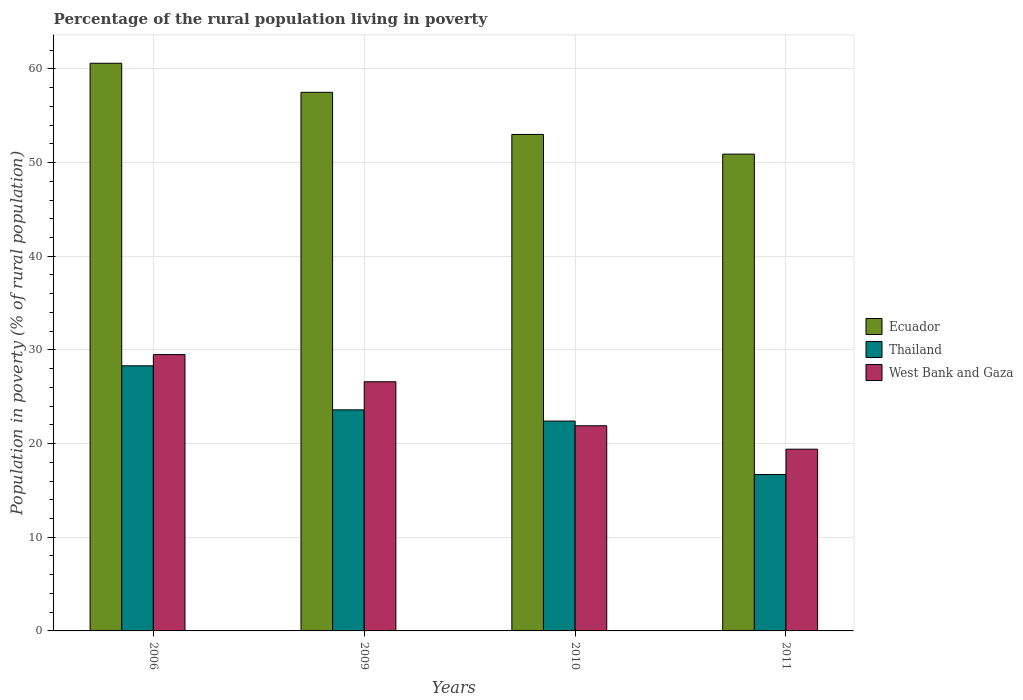How many different coloured bars are there?
Ensure brevity in your answer.  3. How many groups of bars are there?
Give a very brief answer. 4. How many bars are there on the 4th tick from the left?
Your answer should be compact. 3. How many bars are there on the 4th tick from the right?
Make the answer very short. 3. What is the label of the 3rd group of bars from the left?
Provide a succinct answer. 2010. What is the percentage of the rural population living in poverty in West Bank and Gaza in 2009?
Provide a succinct answer. 26.6. Across all years, what is the maximum percentage of the rural population living in poverty in Thailand?
Provide a succinct answer. 28.3. Across all years, what is the minimum percentage of the rural population living in poverty in Thailand?
Provide a short and direct response. 16.7. What is the total percentage of the rural population living in poverty in West Bank and Gaza in the graph?
Your response must be concise. 97.4. What is the difference between the percentage of the rural population living in poverty in Ecuador in 2010 and that in 2011?
Offer a very short reply. 2.1. What is the difference between the percentage of the rural population living in poverty in Ecuador in 2011 and the percentage of the rural population living in poverty in West Bank and Gaza in 2009?
Make the answer very short. 24.3. What is the average percentage of the rural population living in poverty in Thailand per year?
Offer a very short reply. 22.75. In the year 2011, what is the difference between the percentage of the rural population living in poverty in Ecuador and percentage of the rural population living in poverty in West Bank and Gaza?
Provide a short and direct response. 31.5. What is the ratio of the percentage of the rural population living in poverty in Thailand in 2006 to that in 2009?
Provide a short and direct response. 1.2. What is the difference between the highest and the second highest percentage of the rural population living in poverty in Thailand?
Give a very brief answer. 4.7. What is the difference between the highest and the lowest percentage of the rural population living in poverty in Thailand?
Offer a very short reply. 11.6. In how many years, is the percentage of the rural population living in poverty in Thailand greater than the average percentage of the rural population living in poverty in Thailand taken over all years?
Offer a terse response. 2. What does the 2nd bar from the left in 2009 represents?
Provide a succinct answer. Thailand. What does the 1st bar from the right in 2010 represents?
Provide a short and direct response. West Bank and Gaza. What is the difference between two consecutive major ticks on the Y-axis?
Ensure brevity in your answer.  10. Does the graph contain grids?
Offer a terse response. Yes. How many legend labels are there?
Give a very brief answer. 3. What is the title of the graph?
Offer a very short reply. Percentage of the rural population living in poverty. What is the label or title of the X-axis?
Make the answer very short. Years. What is the label or title of the Y-axis?
Offer a terse response. Population in poverty (% of rural population). What is the Population in poverty (% of rural population) in Ecuador in 2006?
Offer a terse response. 60.6. What is the Population in poverty (% of rural population) of Thailand in 2006?
Offer a very short reply. 28.3. What is the Population in poverty (% of rural population) of West Bank and Gaza in 2006?
Your answer should be compact. 29.5. What is the Population in poverty (% of rural population) in Ecuador in 2009?
Provide a succinct answer. 57.5. What is the Population in poverty (% of rural population) of Thailand in 2009?
Keep it short and to the point. 23.6. What is the Population in poverty (% of rural population) in West Bank and Gaza in 2009?
Provide a succinct answer. 26.6. What is the Population in poverty (% of rural population) of Ecuador in 2010?
Provide a short and direct response. 53. What is the Population in poverty (% of rural population) in Thailand in 2010?
Your answer should be very brief. 22.4. What is the Population in poverty (% of rural population) in West Bank and Gaza in 2010?
Your answer should be very brief. 21.9. What is the Population in poverty (% of rural population) in Ecuador in 2011?
Offer a terse response. 50.9. What is the Population in poverty (% of rural population) of Thailand in 2011?
Your answer should be very brief. 16.7. What is the Population in poverty (% of rural population) in West Bank and Gaza in 2011?
Keep it short and to the point. 19.4. Across all years, what is the maximum Population in poverty (% of rural population) of Ecuador?
Your answer should be very brief. 60.6. Across all years, what is the maximum Population in poverty (% of rural population) of Thailand?
Make the answer very short. 28.3. Across all years, what is the maximum Population in poverty (% of rural population) in West Bank and Gaza?
Provide a short and direct response. 29.5. Across all years, what is the minimum Population in poverty (% of rural population) of Ecuador?
Provide a succinct answer. 50.9. What is the total Population in poverty (% of rural population) in Ecuador in the graph?
Your answer should be very brief. 222. What is the total Population in poverty (% of rural population) in Thailand in the graph?
Your answer should be compact. 91. What is the total Population in poverty (% of rural population) of West Bank and Gaza in the graph?
Ensure brevity in your answer.  97.4. What is the difference between the Population in poverty (% of rural population) of Ecuador in 2006 and that in 2009?
Your answer should be compact. 3.1. What is the difference between the Population in poverty (% of rural population) of Thailand in 2006 and that in 2010?
Offer a terse response. 5.9. What is the difference between the Population in poverty (% of rural population) of Ecuador in 2006 and that in 2011?
Offer a terse response. 9.7. What is the difference between the Population in poverty (% of rural population) of Thailand in 2006 and that in 2011?
Offer a terse response. 11.6. What is the difference between the Population in poverty (% of rural population) of Thailand in 2009 and that in 2010?
Your answer should be compact. 1.2. What is the difference between the Population in poverty (% of rural population) of West Bank and Gaza in 2009 and that in 2010?
Keep it short and to the point. 4.7. What is the difference between the Population in poverty (% of rural population) of West Bank and Gaza in 2010 and that in 2011?
Your response must be concise. 2.5. What is the difference between the Population in poverty (% of rural population) in Ecuador in 2006 and the Population in poverty (% of rural population) in Thailand in 2009?
Your response must be concise. 37. What is the difference between the Population in poverty (% of rural population) of Ecuador in 2006 and the Population in poverty (% of rural population) of West Bank and Gaza in 2009?
Your response must be concise. 34. What is the difference between the Population in poverty (% of rural population) in Thailand in 2006 and the Population in poverty (% of rural population) in West Bank and Gaza in 2009?
Make the answer very short. 1.7. What is the difference between the Population in poverty (% of rural population) in Ecuador in 2006 and the Population in poverty (% of rural population) in Thailand in 2010?
Ensure brevity in your answer.  38.2. What is the difference between the Population in poverty (% of rural population) in Ecuador in 2006 and the Population in poverty (% of rural population) in West Bank and Gaza in 2010?
Make the answer very short. 38.7. What is the difference between the Population in poverty (% of rural population) in Thailand in 2006 and the Population in poverty (% of rural population) in West Bank and Gaza in 2010?
Ensure brevity in your answer.  6.4. What is the difference between the Population in poverty (% of rural population) in Ecuador in 2006 and the Population in poverty (% of rural population) in Thailand in 2011?
Offer a terse response. 43.9. What is the difference between the Population in poverty (% of rural population) of Ecuador in 2006 and the Population in poverty (% of rural population) of West Bank and Gaza in 2011?
Offer a terse response. 41.2. What is the difference between the Population in poverty (% of rural population) of Thailand in 2006 and the Population in poverty (% of rural population) of West Bank and Gaza in 2011?
Give a very brief answer. 8.9. What is the difference between the Population in poverty (% of rural population) of Ecuador in 2009 and the Population in poverty (% of rural population) of Thailand in 2010?
Your answer should be very brief. 35.1. What is the difference between the Population in poverty (% of rural population) in Ecuador in 2009 and the Population in poverty (% of rural population) in West Bank and Gaza in 2010?
Provide a succinct answer. 35.6. What is the difference between the Population in poverty (% of rural population) of Thailand in 2009 and the Population in poverty (% of rural population) of West Bank and Gaza in 2010?
Keep it short and to the point. 1.7. What is the difference between the Population in poverty (% of rural population) in Ecuador in 2009 and the Population in poverty (% of rural population) in Thailand in 2011?
Offer a terse response. 40.8. What is the difference between the Population in poverty (% of rural population) of Ecuador in 2009 and the Population in poverty (% of rural population) of West Bank and Gaza in 2011?
Make the answer very short. 38.1. What is the difference between the Population in poverty (% of rural population) in Thailand in 2009 and the Population in poverty (% of rural population) in West Bank and Gaza in 2011?
Your response must be concise. 4.2. What is the difference between the Population in poverty (% of rural population) of Ecuador in 2010 and the Population in poverty (% of rural population) of Thailand in 2011?
Provide a succinct answer. 36.3. What is the difference between the Population in poverty (% of rural population) of Ecuador in 2010 and the Population in poverty (% of rural population) of West Bank and Gaza in 2011?
Your response must be concise. 33.6. What is the average Population in poverty (% of rural population) of Ecuador per year?
Offer a very short reply. 55.5. What is the average Population in poverty (% of rural population) in Thailand per year?
Keep it short and to the point. 22.75. What is the average Population in poverty (% of rural population) in West Bank and Gaza per year?
Make the answer very short. 24.35. In the year 2006, what is the difference between the Population in poverty (% of rural population) of Ecuador and Population in poverty (% of rural population) of Thailand?
Give a very brief answer. 32.3. In the year 2006, what is the difference between the Population in poverty (% of rural population) of Ecuador and Population in poverty (% of rural population) of West Bank and Gaza?
Your response must be concise. 31.1. In the year 2006, what is the difference between the Population in poverty (% of rural population) of Thailand and Population in poverty (% of rural population) of West Bank and Gaza?
Provide a succinct answer. -1.2. In the year 2009, what is the difference between the Population in poverty (% of rural population) of Ecuador and Population in poverty (% of rural population) of Thailand?
Your response must be concise. 33.9. In the year 2009, what is the difference between the Population in poverty (% of rural population) of Ecuador and Population in poverty (% of rural population) of West Bank and Gaza?
Your answer should be compact. 30.9. In the year 2010, what is the difference between the Population in poverty (% of rural population) in Ecuador and Population in poverty (% of rural population) in Thailand?
Ensure brevity in your answer.  30.6. In the year 2010, what is the difference between the Population in poverty (% of rural population) in Ecuador and Population in poverty (% of rural population) in West Bank and Gaza?
Offer a very short reply. 31.1. In the year 2011, what is the difference between the Population in poverty (% of rural population) of Ecuador and Population in poverty (% of rural population) of Thailand?
Make the answer very short. 34.2. In the year 2011, what is the difference between the Population in poverty (% of rural population) in Ecuador and Population in poverty (% of rural population) in West Bank and Gaza?
Provide a short and direct response. 31.5. What is the ratio of the Population in poverty (% of rural population) in Ecuador in 2006 to that in 2009?
Give a very brief answer. 1.05. What is the ratio of the Population in poverty (% of rural population) of Thailand in 2006 to that in 2009?
Provide a short and direct response. 1.2. What is the ratio of the Population in poverty (% of rural population) in West Bank and Gaza in 2006 to that in 2009?
Offer a terse response. 1.11. What is the ratio of the Population in poverty (% of rural population) of Ecuador in 2006 to that in 2010?
Your response must be concise. 1.14. What is the ratio of the Population in poverty (% of rural population) of Thailand in 2006 to that in 2010?
Make the answer very short. 1.26. What is the ratio of the Population in poverty (% of rural population) in West Bank and Gaza in 2006 to that in 2010?
Provide a short and direct response. 1.35. What is the ratio of the Population in poverty (% of rural population) in Ecuador in 2006 to that in 2011?
Ensure brevity in your answer.  1.19. What is the ratio of the Population in poverty (% of rural population) of Thailand in 2006 to that in 2011?
Keep it short and to the point. 1.69. What is the ratio of the Population in poverty (% of rural population) in West Bank and Gaza in 2006 to that in 2011?
Make the answer very short. 1.52. What is the ratio of the Population in poverty (% of rural population) of Ecuador in 2009 to that in 2010?
Give a very brief answer. 1.08. What is the ratio of the Population in poverty (% of rural population) in Thailand in 2009 to that in 2010?
Your answer should be compact. 1.05. What is the ratio of the Population in poverty (% of rural population) of West Bank and Gaza in 2009 to that in 2010?
Offer a very short reply. 1.21. What is the ratio of the Population in poverty (% of rural population) of Ecuador in 2009 to that in 2011?
Offer a terse response. 1.13. What is the ratio of the Population in poverty (% of rural population) of Thailand in 2009 to that in 2011?
Provide a succinct answer. 1.41. What is the ratio of the Population in poverty (% of rural population) of West Bank and Gaza in 2009 to that in 2011?
Give a very brief answer. 1.37. What is the ratio of the Population in poverty (% of rural population) of Ecuador in 2010 to that in 2011?
Your answer should be compact. 1.04. What is the ratio of the Population in poverty (% of rural population) of Thailand in 2010 to that in 2011?
Your answer should be compact. 1.34. What is the ratio of the Population in poverty (% of rural population) of West Bank and Gaza in 2010 to that in 2011?
Offer a terse response. 1.13. What is the difference between the highest and the second highest Population in poverty (% of rural population) of Thailand?
Your answer should be very brief. 4.7. What is the difference between the highest and the lowest Population in poverty (% of rural population) in Ecuador?
Provide a succinct answer. 9.7. What is the difference between the highest and the lowest Population in poverty (% of rural population) in Thailand?
Your answer should be very brief. 11.6. What is the difference between the highest and the lowest Population in poverty (% of rural population) in West Bank and Gaza?
Keep it short and to the point. 10.1. 